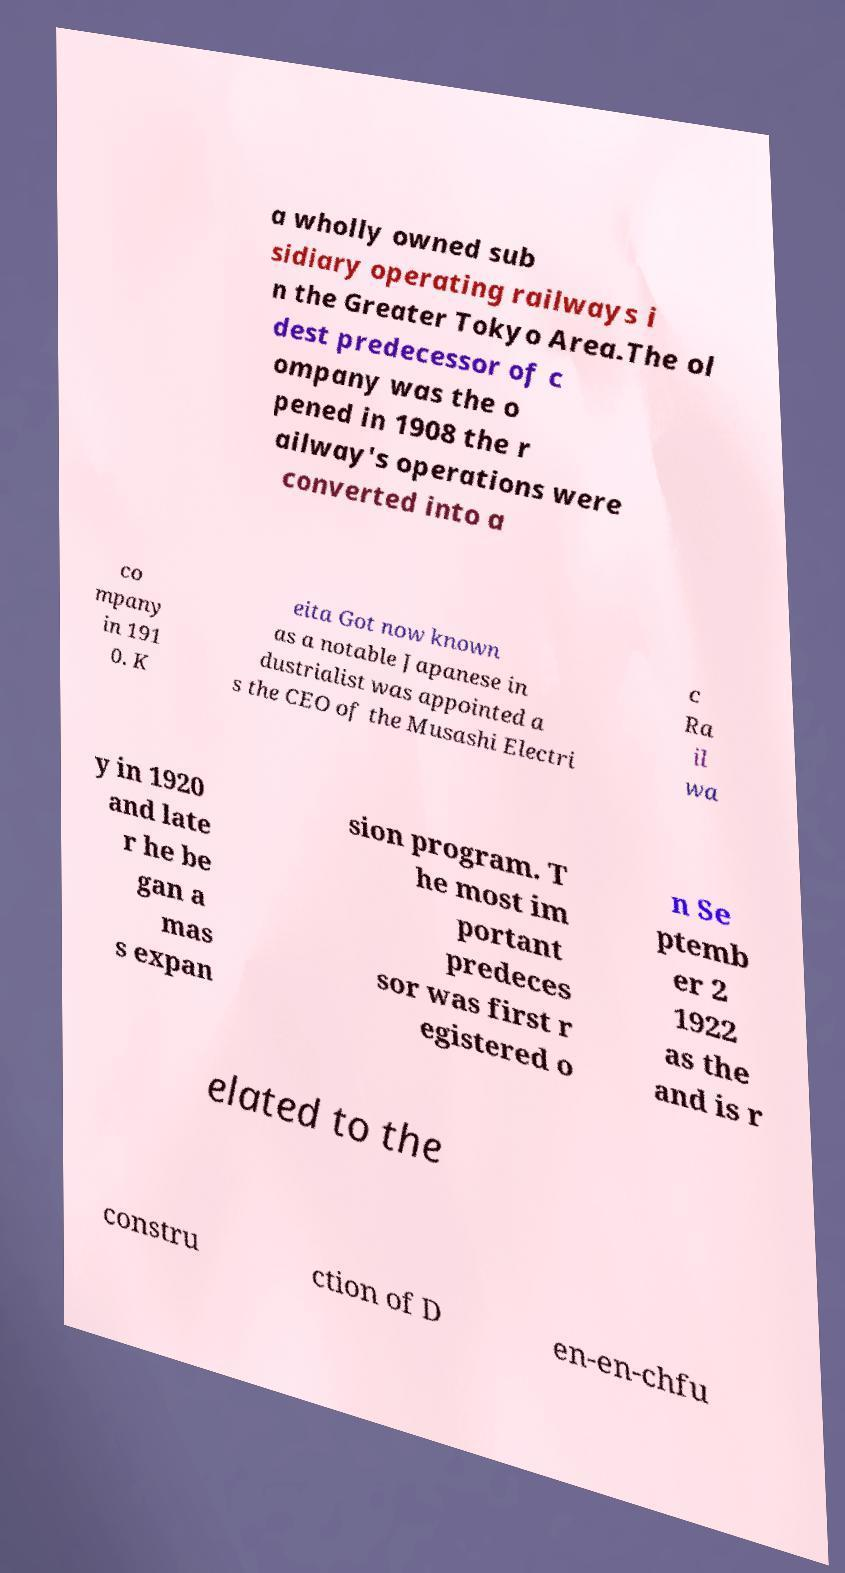Could you extract and type out the text from this image? a wholly owned sub sidiary operating railways i n the Greater Tokyo Area.The ol dest predecessor of c ompany was the o pened in 1908 the r ailway's operations were converted into a co mpany in 191 0. K eita Got now known as a notable Japanese in dustrialist was appointed a s the CEO of the Musashi Electri c Ra il wa y in 1920 and late r he be gan a mas s expan sion program. T he most im portant predeces sor was first r egistered o n Se ptemb er 2 1922 as the and is r elated to the constru ction of D en-en-chfu 